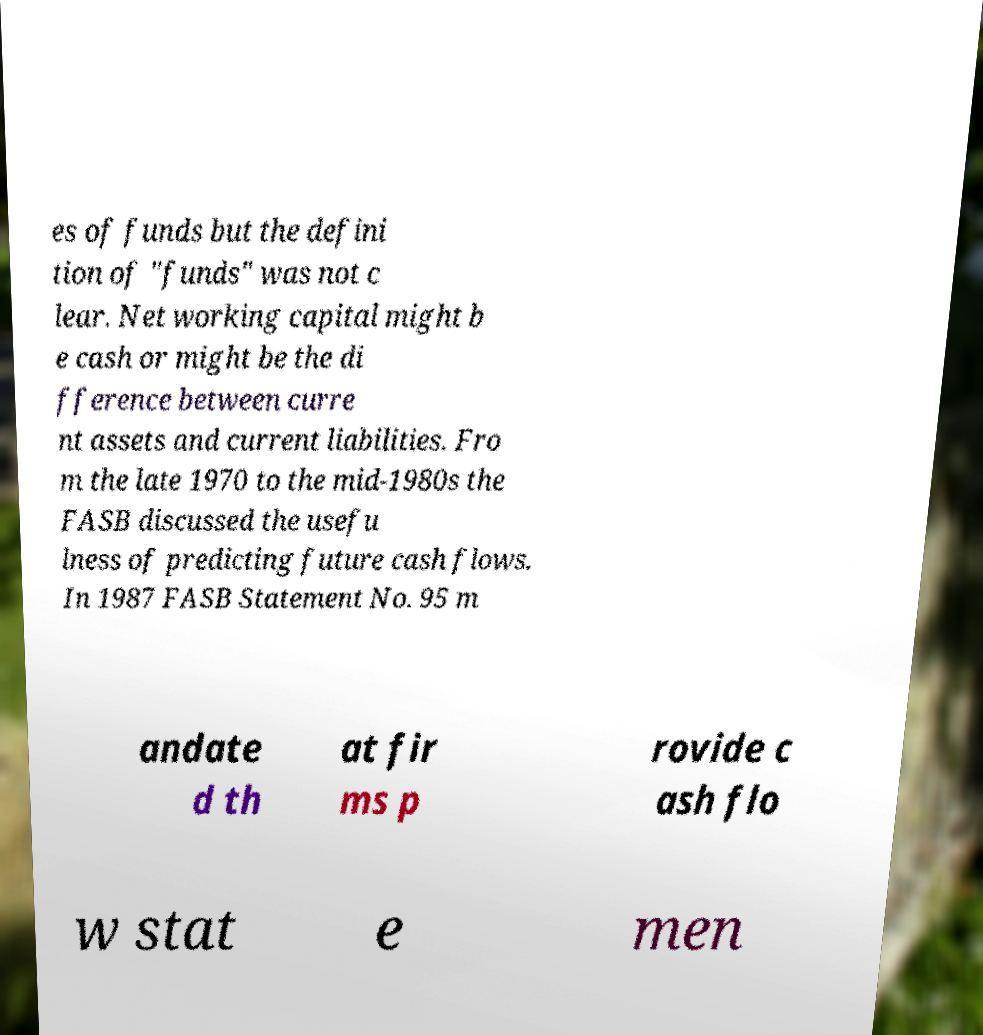Can you read and provide the text displayed in the image?This photo seems to have some interesting text. Can you extract and type it out for me? es of funds but the defini tion of "funds" was not c lear. Net working capital might b e cash or might be the di fference between curre nt assets and current liabilities. Fro m the late 1970 to the mid-1980s the FASB discussed the usefu lness of predicting future cash flows. In 1987 FASB Statement No. 95 m andate d th at fir ms p rovide c ash flo w stat e men 